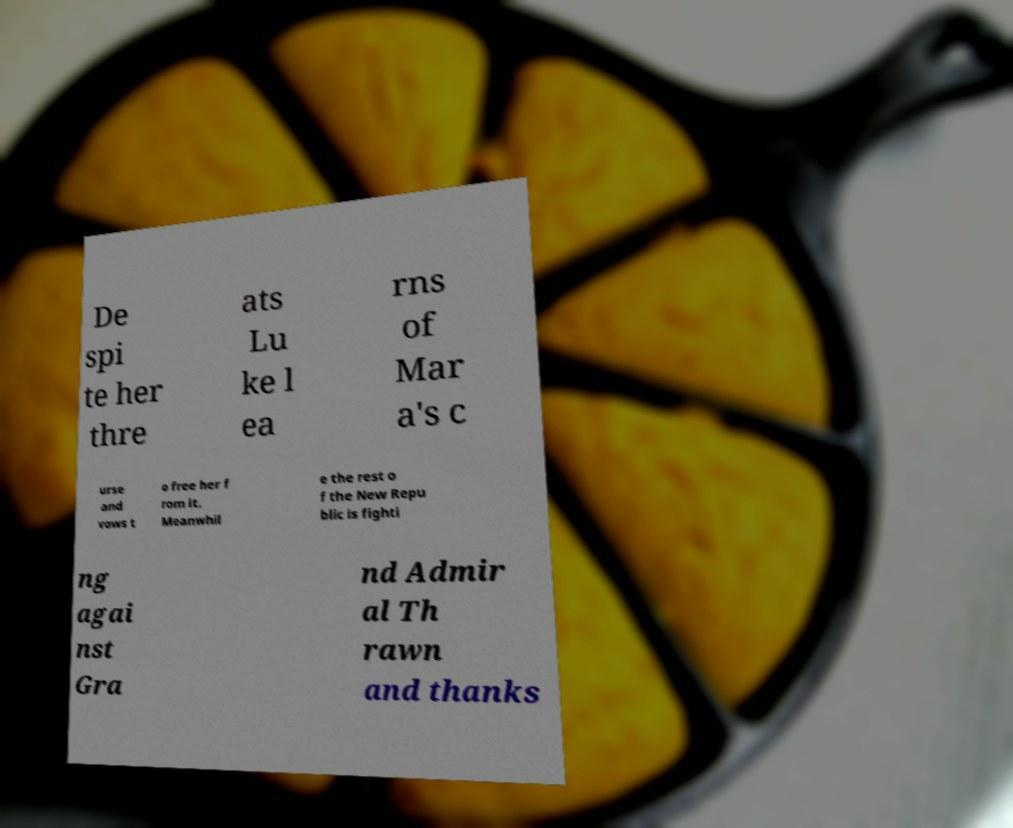I need the written content from this picture converted into text. Can you do that? De spi te her thre ats Lu ke l ea rns of Mar a's c urse and vows t o free her f rom it. Meanwhil e the rest o f the New Repu blic is fighti ng agai nst Gra nd Admir al Th rawn and thanks 